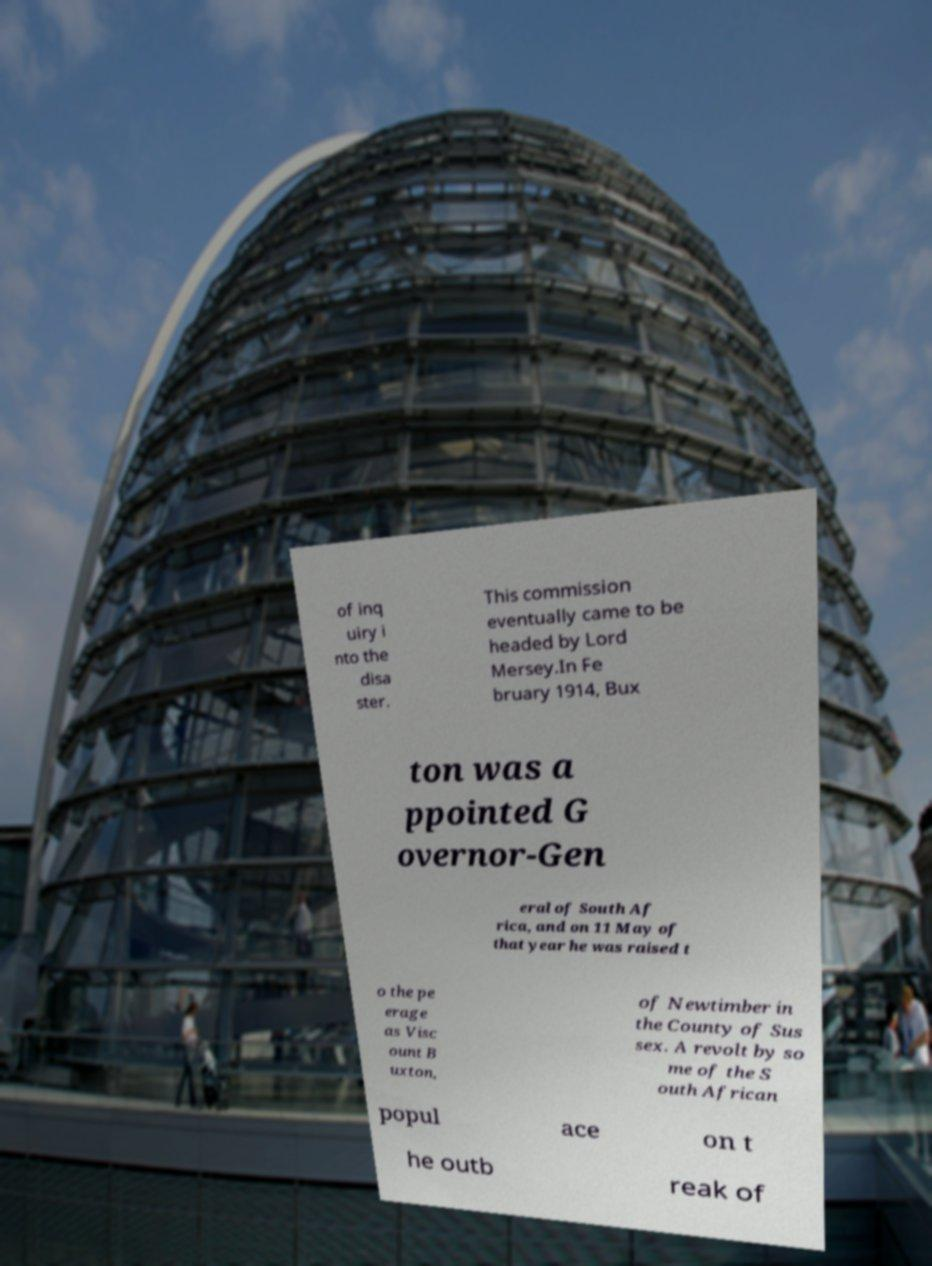Could you assist in decoding the text presented in this image and type it out clearly? of inq uiry i nto the disa ster. This commission eventually came to be headed by Lord Mersey.In Fe bruary 1914, Bux ton was a ppointed G overnor-Gen eral of South Af rica, and on 11 May of that year he was raised t o the pe erage as Visc ount B uxton, of Newtimber in the County of Sus sex. A revolt by so me of the S outh African popul ace on t he outb reak of 